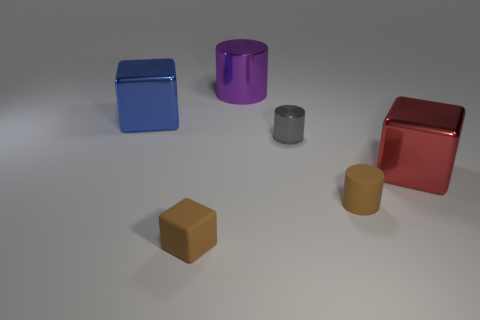Is there any other thing of the same color as the tiny rubber cylinder?
Give a very brief answer. Yes. There is a block that is behind the cube right of the brown cylinder behind the tiny block; what is its material?
Make the answer very short. Metal. Is the tiny gray thing the same shape as the blue object?
Your response must be concise. No. Is there any other thing that is made of the same material as the blue thing?
Keep it short and to the point. Yes. How many things are left of the tiny rubber block and on the right side of the tiny brown block?
Your response must be concise. 0. What is the color of the metallic block to the left of the large block to the right of the brown cylinder?
Your response must be concise. Blue. Are there an equal number of tiny cubes behind the gray cylinder and small brown matte cylinders?
Make the answer very short. No. What number of tiny brown matte cubes are left of the tiny object in front of the brown matte object that is right of the tiny gray cylinder?
Offer a terse response. 0. What is the color of the big thing that is in front of the big blue metal thing?
Offer a terse response. Red. What material is the big thing that is behind the small gray metal cylinder and on the right side of the rubber cube?
Keep it short and to the point. Metal. 